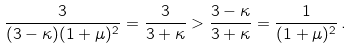<formula> <loc_0><loc_0><loc_500><loc_500>\frac { 3 } { ( 3 - \kappa ) ( 1 + \mu ) ^ { 2 } } = \frac { 3 } { 3 + \kappa } > \frac { 3 - \kappa } { 3 + \kappa } = \frac { 1 } { ( 1 + \mu ) ^ { 2 } } \, .</formula> 